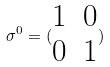<formula> <loc_0><loc_0><loc_500><loc_500>\sigma ^ { 0 } = ( \begin{matrix} 1 & 0 \\ 0 & 1 \\ \end{matrix} )</formula> 